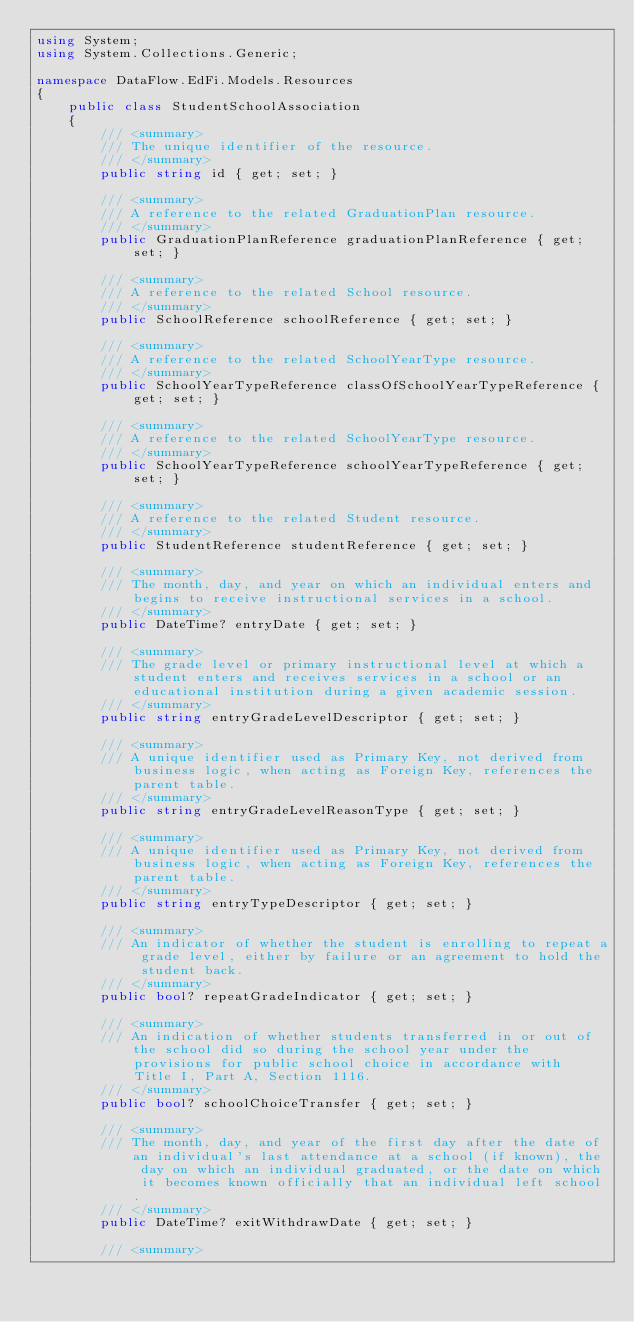Convert code to text. <code><loc_0><loc_0><loc_500><loc_500><_C#_>using System;
using System.Collections.Generic;

namespace DataFlow.EdFi.Models.Resources 
{
    public class StudentSchoolAssociation 
    {
        /// <summary>
        /// The unique identifier of the resource.
        /// </summary>
        public string id { get; set; }

        /// <summary>
        /// A reference to the related GraduationPlan resource.
        /// </summary>
        public GraduationPlanReference graduationPlanReference { get; set; }

        /// <summary>
        /// A reference to the related School resource.
        /// </summary>
        public SchoolReference schoolReference { get; set; }

        /// <summary>
        /// A reference to the related SchoolYearType resource.
        /// </summary>
        public SchoolYearTypeReference classOfSchoolYearTypeReference { get; set; }

        /// <summary>
        /// A reference to the related SchoolYearType resource.
        /// </summary>
        public SchoolYearTypeReference schoolYearTypeReference { get; set; }

        /// <summary>
        /// A reference to the related Student resource.
        /// </summary>
        public StudentReference studentReference { get; set; }

        /// <summary>
        /// The month, day, and year on which an individual enters and begins to receive instructional services in a school.
        /// </summary>
        public DateTime? entryDate { get; set; }

        /// <summary>
        /// The grade level or primary instructional level at which a student enters and receives services in a school or an educational institution during a given academic session.
        /// </summary>
        public string entryGradeLevelDescriptor { get; set; }

        /// <summary>
        /// A unique identifier used as Primary Key, not derived from business logic, when acting as Foreign Key, references the parent table.
        /// </summary>
        public string entryGradeLevelReasonType { get; set; }

        /// <summary>
        /// A unique identifier used as Primary Key, not derived from business logic, when acting as Foreign Key, references the parent table.
        /// </summary>
        public string entryTypeDescriptor { get; set; }

        /// <summary>
        /// An indicator of whether the student is enrolling to repeat a grade level, either by failure or an agreement to hold the student back.
        /// </summary>
        public bool? repeatGradeIndicator { get; set; }

        /// <summary>
        /// An indication of whether students transferred in or out of the school did so during the school year under the provisions for public school choice in accordance with Title I, Part A, Section 1116.
        /// </summary>
        public bool? schoolChoiceTransfer { get; set; }

        /// <summary>
        /// The month, day, and year of the first day after the date of an individual's last attendance at a school (if known), the day on which an individual graduated, or the date on which it becomes known officially that an individual left school.
        /// </summary>
        public DateTime? exitWithdrawDate { get; set; }

        /// <summary></code> 